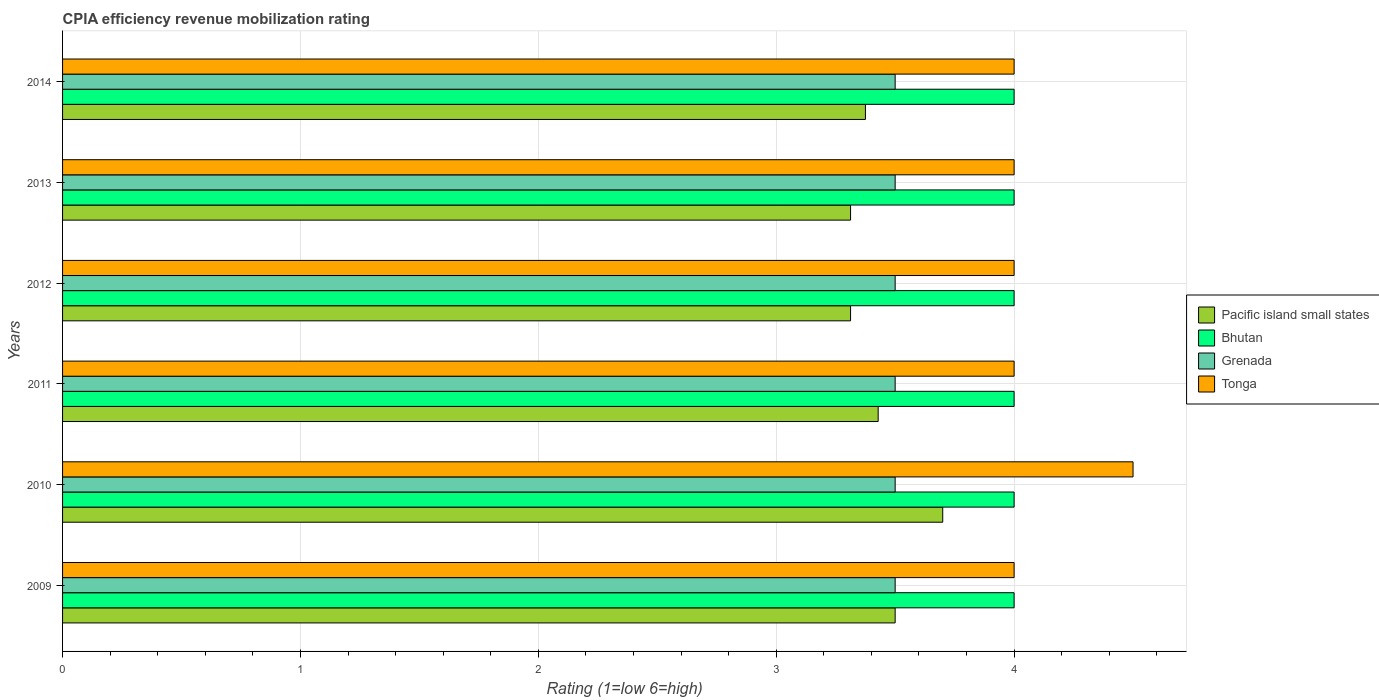Are the number of bars per tick equal to the number of legend labels?
Keep it short and to the point. Yes. How many bars are there on the 4th tick from the bottom?
Give a very brief answer. 4. What is the label of the 5th group of bars from the top?
Your answer should be compact. 2010. Across all years, what is the maximum CPIA rating in Bhutan?
Make the answer very short. 4. Across all years, what is the minimum CPIA rating in Bhutan?
Ensure brevity in your answer.  4. In which year was the CPIA rating in Pacific island small states maximum?
Provide a short and direct response. 2010. What is the total CPIA rating in Pacific island small states in the graph?
Offer a terse response. 20.63. What is the difference between the CPIA rating in Pacific island small states in 2010 and that in 2012?
Your answer should be very brief. 0.39. What is the difference between the CPIA rating in Tonga in 2014 and the CPIA rating in Bhutan in 2013?
Your answer should be compact. 0. What is the average CPIA rating in Pacific island small states per year?
Your answer should be compact. 3.44. In the year 2011, what is the difference between the CPIA rating in Tonga and CPIA rating in Bhutan?
Keep it short and to the point. 0. What is the difference between the highest and the second highest CPIA rating in Pacific island small states?
Keep it short and to the point. 0.2. What is the difference between the highest and the lowest CPIA rating in Bhutan?
Your answer should be very brief. 0. In how many years, is the CPIA rating in Bhutan greater than the average CPIA rating in Bhutan taken over all years?
Make the answer very short. 0. What does the 4th bar from the top in 2009 represents?
Offer a very short reply. Pacific island small states. What does the 1st bar from the bottom in 2009 represents?
Keep it short and to the point. Pacific island small states. Is it the case that in every year, the sum of the CPIA rating in Grenada and CPIA rating in Bhutan is greater than the CPIA rating in Tonga?
Offer a very short reply. Yes. How many bars are there?
Your answer should be compact. 24. Are all the bars in the graph horizontal?
Your response must be concise. Yes. How many years are there in the graph?
Provide a succinct answer. 6. Does the graph contain any zero values?
Your response must be concise. No. Does the graph contain grids?
Provide a short and direct response. Yes. How are the legend labels stacked?
Your answer should be very brief. Vertical. What is the title of the graph?
Your answer should be very brief. CPIA efficiency revenue mobilization rating. What is the label or title of the X-axis?
Ensure brevity in your answer.  Rating (1=low 6=high). What is the label or title of the Y-axis?
Make the answer very short. Years. What is the Rating (1=low 6=high) of Pacific island small states in 2009?
Make the answer very short. 3.5. What is the Rating (1=low 6=high) in Bhutan in 2009?
Your response must be concise. 4. What is the Rating (1=low 6=high) in Tonga in 2009?
Your response must be concise. 4. What is the Rating (1=low 6=high) of Bhutan in 2010?
Your answer should be compact. 4. What is the Rating (1=low 6=high) of Grenada in 2010?
Offer a very short reply. 3.5. What is the Rating (1=low 6=high) of Pacific island small states in 2011?
Your answer should be very brief. 3.43. What is the Rating (1=low 6=high) in Bhutan in 2011?
Your answer should be very brief. 4. What is the Rating (1=low 6=high) in Grenada in 2011?
Your response must be concise. 3.5. What is the Rating (1=low 6=high) in Pacific island small states in 2012?
Offer a terse response. 3.31. What is the Rating (1=low 6=high) in Bhutan in 2012?
Your answer should be very brief. 4. What is the Rating (1=low 6=high) in Grenada in 2012?
Offer a very short reply. 3.5. What is the Rating (1=low 6=high) in Tonga in 2012?
Provide a succinct answer. 4. What is the Rating (1=low 6=high) of Pacific island small states in 2013?
Offer a very short reply. 3.31. What is the Rating (1=low 6=high) in Pacific island small states in 2014?
Your answer should be compact. 3.38. What is the Rating (1=low 6=high) in Bhutan in 2014?
Make the answer very short. 4. What is the Rating (1=low 6=high) of Grenada in 2014?
Your answer should be compact. 3.5. Across all years, what is the maximum Rating (1=low 6=high) in Pacific island small states?
Give a very brief answer. 3.7. Across all years, what is the maximum Rating (1=low 6=high) in Bhutan?
Ensure brevity in your answer.  4. Across all years, what is the minimum Rating (1=low 6=high) in Pacific island small states?
Provide a succinct answer. 3.31. Across all years, what is the minimum Rating (1=low 6=high) in Tonga?
Provide a short and direct response. 4. What is the total Rating (1=low 6=high) of Pacific island small states in the graph?
Ensure brevity in your answer.  20.63. What is the total Rating (1=low 6=high) of Bhutan in the graph?
Keep it short and to the point. 24. What is the total Rating (1=low 6=high) of Grenada in the graph?
Provide a succinct answer. 21. What is the total Rating (1=low 6=high) of Tonga in the graph?
Offer a terse response. 24.5. What is the difference between the Rating (1=low 6=high) of Bhutan in 2009 and that in 2010?
Give a very brief answer. 0. What is the difference between the Rating (1=low 6=high) of Grenada in 2009 and that in 2010?
Provide a short and direct response. 0. What is the difference between the Rating (1=low 6=high) of Tonga in 2009 and that in 2010?
Your answer should be compact. -0.5. What is the difference between the Rating (1=low 6=high) in Pacific island small states in 2009 and that in 2011?
Offer a very short reply. 0.07. What is the difference between the Rating (1=low 6=high) of Grenada in 2009 and that in 2011?
Keep it short and to the point. 0. What is the difference between the Rating (1=low 6=high) of Tonga in 2009 and that in 2011?
Ensure brevity in your answer.  0. What is the difference between the Rating (1=low 6=high) of Pacific island small states in 2009 and that in 2012?
Ensure brevity in your answer.  0.19. What is the difference between the Rating (1=low 6=high) of Grenada in 2009 and that in 2012?
Your answer should be compact. 0. What is the difference between the Rating (1=low 6=high) in Tonga in 2009 and that in 2012?
Keep it short and to the point. 0. What is the difference between the Rating (1=low 6=high) in Pacific island small states in 2009 and that in 2013?
Keep it short and to the point. 0.19. What is the difference between the Rating (1=low 6=high) in Tonga in 2009 and that in 2014?
Ensure brevity in your answer.  0. What is the difference between the Rating (1=low 6=high) in Pacific island small states in 2010 and that in 2011?
Your answer should be compact. 0.27. What is the difference between the Rating (1=low 6=high) of Grenada in 2010 and that in 2011?
Offer a terse response. 0. What is the difference between the Rating (1=low 6=high) in Tonga in 2010 and that in 2011?
Ensure brevity in your answer.  0.5. What is the difference between the Rating (1=low 6=high) of Pacific island small states in 2010 and that in 2012?
Provide a succinct answer. 0.39. What is the difference between the Rating (1=low 6=high) of Bhutan in 2010 and that in 2012?
Offer a very short reply. 0. What is the difference between the Rating (1=low 6=high) in Grenada in 2010 and that in 2012?
Provide a succinct answer. 0. What is the difference between the Rating (1=low 6=high) in Tonga in 2010 and that in 2012?
Your answer should be compact. 0.5. What is the difference between the Rating (1=low 6=high) in Pacific island small states in 2010 and that in 2013?
Provide a short and direct response. 0.39. What is the difference between the Rating (1=low 6=high) of Bhutan in 2010 and that in 2013?
Your answer should be very brief. 0. What is the difference between the Rating (1=low 6=high) in Grenada in 2010 and that in 2013?
Your response must be concise. 0. What is the difference between the Rating (1=low 6=high) in Pacific island small states in 2010 and that in 2014?
Your response must be concise. 0.33. What is the difference between the Rating (1=low 6=high) of Pacific island small states in 2011 and that in 2012?
Offer a terse response. 0.12. What is the difference between the Rating (1=low 6=high) of Bhutan in 2011 and that in 2012?
Provide a succinct answer. 0. What is the difference between the Rating (1=low 6=high) in Tonga in 2011 and that in 2012?
Give a very brief answer. 0. What is the difference between the Rating (1=low 6=high) of Pacific island small states in 2011 and that in 2013?
Your answer should be very brief. 0.12. What is the difference between the Rating (1=low 6=high) in Bhutan in 2011 and that in 2013?
Offer a terse response. 0. What is the difference between the Rating (1=low 6=high) of Grenada in 2011 and that in 2013?
Give a very brief answer. 0. What is the difference between the Rating (1=low 6=high) in Pacific island small states in 2011 and that in 2014?
Give a very brief answer. 0.05. What is the difference between the Rating (1=low 6=high) of Bhutan in 2011 and that in 2014?
Keep it short and to the point. 0. What is the difference between the Rating (1=low 6=high) of Grenada in 2011 and that in 2014?
Your answer should be very brief. 0. What is the difference between the Rating (1=low 6=high) in Grenada in 2012 and that in 2013?
Ensure brevity in your answer.  0. What is the difference between the Rating (1=low 6=high) of Tonga in 2012 and that in 2013?
Provide a short and direct response. 0. What is the difference between the Rating (1=low 6=high) of Pacific island small states in 2012 and that in 2014?
Keep it short and to the point. -0.06. What is the difference between the Rating (1=low 6=high) in Bhutan in 2012 and that in 2014?
Provide a short and direct response. 0. What is the difference between the Rating (1=low 6=high) in Pacific island small states in 2013 and that in 2014?
Your answer should be very brief. -0.06. What is the difference between the Rating (1=low 6=high) in Bhutan in 2013 and that in 2014?
Your answer should be very brief. 0. What is the difference between the Rating (1=low 6=high) in Grenada in 2013 and that in 2014?
Make the answer very short. 0. What is the difference between the Rating (1=low 6=high) of Pacific island small states in 2009 and the Rating (1=low 6=high) of Bhutan in 2010?
Keep it short and to the point. -0.5. What is the difference between the Rating (1=low 6=high) in Bhutan in 2009 and the Rating (1=low 6=high) in Grenada in 2010?
Offer a very short reply. 0.5. What is the difference between the Rating (1=low 6=high) in Bhutan in 2009 and the Rating (1=low 6=high) in Tonga in 2010?
Your response must be concise. -0.5. What is the difference between the Rating (1=low 6=high) of Pacific island small states in 2009 and the Rating (1=low 6=high) of Grenada in 2011?
Your answer should be compact. 0. What is the difference between the Rating (1=low 6=high) of Bhutan in 2009 and the Rating (1=low 6=high) of Grenada in 2011?
Ensure brevity in your answer.  0.5. What is the difference between the Rating (1=low 6=high) in Bhutan in 2009 and the Rating (1=low 6=high) in Tonga in 2011?
Ensure brevity in your answer.  0. What is the difference between the Rating (1=low 6=high) in Pacific island small states in 2009 and the Rating (1=low 6=high) in Bhutan in 2012?
Offer a terse response. -0.5. What is the difference between the Rating (1=low 6=high) of Pacific island small states in 2009 and the Rating (1=low 6=high) of Tonga in 2012?
Keep it short and to the point. -0.5. What is the difference between the Rating (1=low 6=high) of Bhutan in 2009 and the Rating (1=low 6=high) of Tonga in 2012?
Your response must be concise. 0. What is the difference between the Rating (1=low 6=high) of Grenada in 2009 and the Rating (1=low 6=high) of Tonga in 2013?
Provide a short and direct response. -0.5. What is the difference between the Rating (1=low 6=high) of Pacific island small states in 2009 and the Rating (1=low 6=high) of Tonga in 2014?
Keep it short and to the point. -0.5. What is the difference between the Rating (1=low 6=high) of Bhutan in 2009 and the Rating (1=low 6=high) of Grenada in 2014?
Ensure brevity in your answer.  0.5. What is the difference between the Rating (1=low 6=high) of Pacific island small states in 2010 and the Rating (1=low 6=high) of Bhutan in 2011?
Offer a terse response. -0.3. What is the difference between the Rating (1=low 6=high) of Pacific island small states in 2010 and the Rating (1=low 6=high) of Grenada in 2011?
Provide a succinct answer. 0.2. What is the difference between the Rating (1=low 6=high) in Bhutan in 2010 and the Rating (1=low 6=high) in Grenada in 2011?
Your response must be concise. 0.5. What is the difference between the Rating (1=low 6=high) in Bhutan in 2010 and the Rating (1=low 6=high) in Tonga in 2011?
Provide a succinct answer. 0. What is the difference between the Rating (1=low 6=high) in Pacific island small states in 2010 and the Rating (1=low 6=high) in Grenada in 2012?
Offer a terse response. 0.2. What is the difference between the Rating (1=low 6=high) in Bhutan in 2010 and the Rating (1=low 6=high) in Grenada in 2012?
Give a very brief answer. 0.5. What is the difference between the Rating (1=low 6=high) in Bhutan in 2010 and the Rating (1=low 6=high) in Tonga in 2012?
Keep it short and to the point. 0. What is the difference between the Rating (1=low 6=high) of Grenada in 2010 and the Rating (1=low 6=high) of Tonga in 2012?
Provide a succinct answer. -0.5. What is the difference between the Rating (1=low 6=high) of Pacific island small states in 2010 and the Rating (1=low 6=high) of Bhutan in 2013?
Make the answer very short. -0.3. What is the difference between the Rating (1=low 6=high) of Pacific island small states in 2010 and the Rating (1=low 6=high) of Grenada in 2013?
Provide a succinct answer. 0.2. What is the difference between the Rating (1=low 6=high) in Pacific island small states in 2010 and the Rating (1=low 6=high) in Tonga in 2013?
Offer a terse response. -0.3. What is the difference between the Rating (1=low 6=high) in Bhutan in 2010 and the Rating (1=low 6=high) in Tonga in 2013?
Provide a short and direct response. 0. What is the difference between the Rating (1=low 6=high) of Grenada in 2010 and the Rating (1=low 6=high) of Tonga in 2013?
Your response must be concise. -0.5. What is the difference between the Rating (1=low 6=high) of Pacific island small states in 2010 and the Rating (1=low 6=high) of Bhutan in 2014?
Provide a short and direct response. -0.3. What is the difference between the Rating (1=low 6=high) in Pacific island small states in 2010 and the Rating (1=low 6=high) in Grenada in 2014?
Offer a very short reply. 0.2. What is the difference between the Rating (1=low 6=high) in Bhutan in 2010 and the Rating (1=low 6=high) in Grenada in 2014?
Provide a short and direct response. 0.5. What is the difference between the Rating (1=low 6=high) in Pacific island small states in 2011 and the Rating (1=low 6=high) in Bhutan in 2012?
Ensure brevity in your answer.  -0.57. What is the difference between the Rating (1=low 6=high) of Pacific island small states in 2011 and the Rating (1=low 6=high) of Grenada in 2012?
Offer a terse response. -0.07. What is the difference between the Rating (1=low 6=high) of Pacific island small states in 2011 and the Rating (1=low 6=high) of Tonga in 2012?
Your answer should be very brief. -0.57. What is the difference between the Rating (1=low 6=high) in Bhutan in 2011 and the Rating (1=low 6=high) in Tonga in 2012?
Give a very brief answer. 0. What is the difference between the Rating (1=low 6=high) in Grenada in 2011 and the Rating (1=low 6=high) in Tonga in 2012?
Offer a terse response. -0.5. What is the difference between the Rating (1=low 6=high) in Pacific island small states in 2011 and the Rating (1=low 6=high) in Bhutan in 2013?
Your answer should be compact. -0.57. What is the difference between the Rating (1=low 6=high) in Pacific island small states in 2011 and the Rating (1=low 6=high) in Grenada in 2013?
Provide a short and direct response. -0.07. What is the difference between the Rating (1=low 6=high) of Pacific island small states in 2011 and the Rating (1=low 6=high) of Tonga in 2013?
Offer a terse response. -0.57. What is the difference between the Rating (1=low 6=high) in Pacific island small states in 2011 and the Rating (1=low 6=high) in Bhutan in 2014?
Give a very brief answer. -0.57. What is the difference between the Rating (1=low 6=high) of Pacific island small states in 2011 and the Rating (1=low 6=high) of Grenada in 2014?
Ensure brevity in your answer.  -0.07. What is the difference between the Rating (1=low 6=high) in Pacific island small states in 2011 and the Rating (1=low 6=high) in Tonga in 2014?
Ensure brevity in your answer.  -0.57. What is the difference between the Rating (1=low 6=high) in Grenada in 2011 and the Rating (1=low 6=high) in Tonga in 2014?
Ensure brevity in your answer.  -0.5. What is the difference between the Rating (1=low 6=high) of Pacific island small states in 2012 and the Rating (1=low 6=high) of Bhutan in 2013?
Your response must be concise. -0.69. What is the difference between the Rating (1=low 6=high) of Pacific island small states in 2012 and the Rating (1=low 6=high) of Grenada in 2013?
Offer a very short reply. -0.19. What is the difference between the Rating (1=low 6=high) of Pacific island small states in 2012 and the Rating (1=low 6=high) of Tonga in 2013?
Your answer should be compact. -0.69. What is the difference between the Rating (1=low 6=high) of Grenada in 2012 and the Rating (1=low 6=high) of Tonga in 2013?
Give a very brief answer. -0.5. What is the difference between the Rating (1=low 6=high) of Pacific island small states in 2012 and the Rating (1=low 6=high) of Bhutan in 2014?
Make the answer very short. -0.69. What is the difference between the Rating (1=low 6=high) in Pacific island small states in 2012 and the Rating (1=low 6=high) in Grenada in 2014?
Provide a succinct answer. -0.19. What is the difference between the Rating (1=low 6=high) in Pacific island small states in 2012 and the Rating (1=low 6=high) in Tonga in 2014?
Offer a terse response. -0.69. What is the difference between the Rating (1=low 6=high) of Bhutan in 2012 and the Rating (1=low 6=high) of Grenada in 2014?
Your answer should be compact. 0.5. What is the difference between the Rating (1=low 6=high) in Grenada in 2012 and the Rating (1=low 6=high) in Tonga in 2014?
Keep it short and to the point. -0.5. What is the difference between the Rating (1=low 6=high) in Pacific island small states in 2013 and the Rating (1=low 6=high) in Bhutan in 2014?
Offer a very short reply. -0.69. What is the difference between the Rating (1=low 6=high) in Pacific island small states in 2013 and the Rating (1=low 6=high) in Grenada in 2014?
Your answer should be very brief. -0.19. What is the difference between the Rating (1=low 6=high) in Pacific island small states in 2013 and the Rating (1=low 6=high) in Tonga in 2014?
Your response must be concise. -0.69. What is the difference between the Rating (1=low 6=high) of Bhutan in 2013 and the Rating (1=low 6=high) of Grenada in 2014?
Make the answer very short. 0.5. What is the average Rating (1=low 6=high) in Pacific island small states per year?
Provide a succinct answer. 3.44. What is the average Rating (1=low 6=high) in Bhutan per year?
Make the answer very short. 4. What is the average Rating (1=low 6=high) of Tonga per year?
Your answer should be very brief. 4.08. In the year 2009, what is the difference between the Rating (1=low 6=high) in Pacific island small states and Rating (1=low 6=high) in Grenada?
Keep it short and to the point. 0. In the year 2009, what is the difference between the Rating (1=low 6=high) of Pacific island small states and Rating (1=low 6=high) of Tonga?
Keep it short and to the point. -0.5. In the year 2009, what is the difference between the Rating (1=low 6=high) of Bhutan and Rating (1=low 6=high) of Grenada?
Your response must be concise. 0.5. In the year 2009, what is the difference between the Rating (1=low 6=high) in Bhutan and Rating (1=low 6=high) in Tonga?
Your answer should be compact. 0. In the year 2010, what is the difference between the Rating (1=low 6=high) of Pacific island small states and Rating (1=low 6=high) of Tonga?
Keep it short and to the point. -0.8. In the year 2010, what is the difference between the Rating (1=low 6=high) of Bhutan and Rating (1=low 6=high) of Tonga?
Ensure brevity in your answer.  -0.5. In the year 2010, what is the difference between the Rating (1=low 6=high) in Grenada and Rating (1=low 6=high) in Tonga?
Give a very brief answer. -1. In the year 2011, what is the difference between the Rating (1=low 6=high) of Pacific island small states and Rating (1=low 6=high) of Bhutan?
Provide a succinct answer. -0.57. In the year 2011, what is the difference between the Rating (1=low 6=high) of Pacific island small states and Rating (1=low 6=high) of Grenada?
Ensure brevity in your answer.  -0.07. In the year 2011, what is the difference between the Rating (1=low 6=high) in Pacific island small states and Rating (1=low 6=high) in Tonga?
Ensure brevity in your answer.  -0.57. In the year 2011, what is the difference between the Rating (1=low 6=high) of Bhutan and Rating (1=low 6=high) of Grenada?
Your response must be concise. 0.5. In the year 2012, what is the difference between the Rating (1=low 6=high) of Pacific island small states and Rating (1=low 6=high) of Bhutan?
Your answer should be compact. -0.69. In the year 2012, what is the difference between the Rating (1=low 6=high) in Pacific island small states and Rating (1=low 6=high) in Grenada?
Your response must be concise. -0.19. In the year 2012, what is the difference between the Rating (1=low 6=high) in Pacific island small states and Rating (1=low 6=high) in Tonga?
Provide a short and direct response. -0.69. In the year 2012, what is the difference between the Rating (1=low 6=high) in Bhutan and Rating (1=low 6=high) in Grenada?
Your response must be concise. 0.5. In the year 2012, what is the difference between the Rating (1=low 6=high) in Bhutan and Rating (1=low 6=high) in Tonga?
Make the answer very short. 0. In the year 2013, what is the difference between the Rating (1=low 6=high) in Pacific island small states and Rating (1=low 6=high) in Bhutan?
Keep it short and to the point. -0.69. In the year 2013, what is the difference between the Rating (1=low 6=high) of Pacific island small states and Rating (1=low 6=high) of Grenada?
Provide a succinct answer. -0.19. In the year 2013, what is the difference between the Rating (1=low 6=high) of Pacific island small states and Rating (1=low 6=high) of Tonga?
Keep it short and to the point. -0.69. In the year 2013, what is the difference between the Rating (1=low 6=high) in Grenada and Rating (1=low 6=high) in Tonga?
Provide a succinct answer. -0.5. In the year 2014, what is the difference between the Rating (1=low 6=high) of Pacific island small states and Rating (1=low 6=high) of Bhutan?
Offer a very short reply. -0.62. In the year 2014, what is the difference between the Rating (1=low 6=high) of Pacific island small states and Rating (1=low 6=high) of Grenada?
Give a very brief answer. -0.12. In the year 2014, what is the difference between the Rating (1=low 6=high) in Pacific island small states and Rating (1=low 6=high) in Tonga?
Your answer should be compact. -0.62. In the year 2014, what is the difference between the Rating (1=low 6=high) of Bhutan and Rating (1=low 6=high) of Grenada?
Keep it short and to the point. 0.5. In the year 2014, what is the difference between the Rating (1=low 6=high) of Bhutan and Rating (1=low 6=high) of Tonga?
Keep it short and to the point. 0. In the year 2014, what is the difference between the Rating (1=low 6=high) of Grenada and Rating (1=low 6=high) of Tonga?
Your answer should be very brief. -0.5. What is the ratio of the Rating (1=low 6=high) of Pacific island small states in 2009 to that in 2010?
Keep it short and to the point. 0.95. What is the ratio of the Rating (1=low 6=high) of Tonga in 2009 to that in 2010?
Provide a short and direct response. 0.89. What is the ratio of the Rating (1=low 6=high) in Pacific island small states in 2009 to that in 2011?
Your answer should be compact. 1.02. What is the ratio of the Rating (1=low 6=high) in Bhutan in 2009 to that in 2011?
Ensure brevity in your answer.  1. What is the ratio of the Rating (1=low 6=high) in Tonga in 2009 to that in 2011?
Keep it short and to the point. 1. What is the ratio of the Rating (1=low 6=high) in Pacific island small states in 2009 to that in 2012?
Your answer should be very brief. 1.06. What is the ratio of the Rating (1=low 6=high) of Pacific island small states in 2009 to that in 2013?
Keep it short and to the point. 1.06. What is the ratio of the Rating (1=low 6=high) of Grenada in 2009 to that in 2013?
Your answer should be compact. 1. What is the ratio of the Rating (1=low 6=high) of Tonga in 2009 to that in 2013?
Your response must be concise. 1. What is the ratio of the Rating (1=low 6=high) of Pacific island small states in 2010 to that in 2011?
Your response must be concise. 1.08. What is the ratio of the Rating (1=low 6=high) in Pacific island small states in 2010 to that in 2012?
Provide a succinct answer. 1.12. What is the ratio of the Rating (1=low 6=high) of Grenada in 2010 to that in 2012?
Your response must be concise. 1. What is the ratio of the Rating (1=low 6=high) in Tonga in 2010 to that in 2012?
Keep it short and to the point. 1.12. What is the ratio of the Rating (1=low 6=high) in Pacific island small states in 2010 to that in 2013?
Offer a very short reply. 1.12. What is the ratio of the Rating (1=low 6=high) of Tonga in 2010 to that in 2013?
Give a very brief answer. 1.12. What is the ratio of the Rating (1=low 6=high) in Pacific island small states in 2010 to that in 2014?
Provide a short and direct response. 1.1. What is the ratio of the Rating (1=low 6=high) in Bhutan in 2010 to that in 2014?
Offer a terse response. 1. What is the ratio of the Rating (1=low 6=high) of Tonga in 2010 to that in 2014?
Provide a short and direct response. 1.12. What is the ratio of the Rating (1=low 6=high) in Pacific island small states in 2011 to that in 2012?
Your response must be concise. 1.03. What is the ratio of the Rating (1=low 6=high) in Grenada in 2011 to that in 2012?
Offer a very short reply. 1. What is the ratio of the Rating (1=low 6=high) of Tonga in 2011 to that in 2012?
Provide a succinct answer. 1. What is the ratio of the Rating (1=low 6=high) of Pacific island small states in 2011 to that in 2013?
Provide a short and direct response. 1.03. What is the ratio of the Rating (1=low 6=high) of Grenada in 2011 to that in 2013?
Provide a short and direct response. 1. What is the ratio of the Rating (1=low 6=high) in Tonga in 2011 to that in 2013?
Keep it short and to the point. 1. What is the ratio of the Rating (1=low 6=high) in Pacific island small states in 2011 to that in 2014?
Give a very brief answer. 1.02. What is the ratio of the Rating (1=low 6=high) in Tonga in 2011 to that in 2014?
Your answer should be very brief. 1. What is the ratio of the Rating (1=low 6=high) in Pacific island small states in 2012 to that in 2013?
Your answer should be compact. 1. What is the ratio of the Rating (1=low 6=high) in Bhutan in 2012 to that in 2013?
Offer a terse response. 1. What is the ratio of the Rating (1=low 6=high) of Tonga in 2012 to that in 2013?
Ensure brevity in your answer.  1. What is the ratio of the Rating (1=low 6=high) of Pacific island small states in 2012 to that in 2014?
Give a very brief answer. 0.98. What is the ratio of the Rating (1=low 6=high) in Bhutan in 2012 to that in 2014?
Provide a succinct answer. 1. What is the ratio of the Rating (1=low 6=high) of Tonga in 2012 to that in 2014?
Offer a very short reply. 1. What is the ratio of the Rating (1=low 6=high) in Pacific island small states in 2013 to that in 2014?
Provide a succinct answer. 0.98. What is the difference between the highest and the second highest Rating (1=low 6=high) in Pacific island small states?
Give a very brief answer. 0.2. What is the difference between the highest and the second highest Rating (1=low 6=high) in Bhutan?
Keep it short and to the point. 0. What is the difference between the highest and the second highest Rating (1=low 6=high) of Grenada?
Offer a terse response. 0. What is the difference between the highest and the lowest Rating (1=low 6=high) in Pacific island small states?
Provide a short and direct response. 0.39. What is the difference between the highest and the lowest Rating (1=low 6=high) in Bhutan?
Provide a short and direct response. 0. 